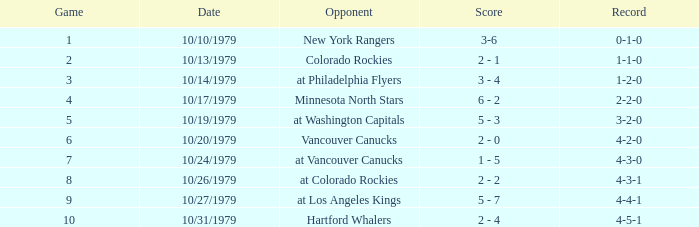Who is the opponent before game 5 with a 0-1-0 record? New York Rangers. 